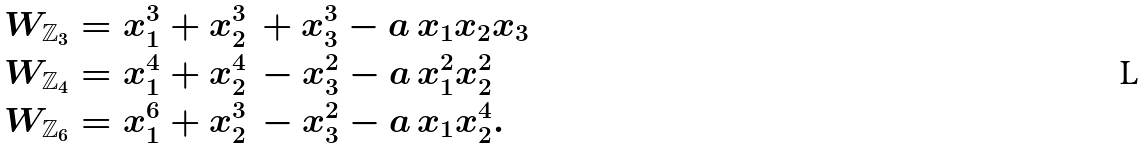Convert formula to latex. <formula><loc_0><loc_0><loc_500><loc_500>W _ { \mathbb { Z } _ { 3 } } & = x _ { 1 } ^ { 3 } + x _ { 2 } ^ { 3 } \, + x _ { 3 } ^ { 3 } - a \, x _ { 1 } x _ { 2 } x _ { 3 } \\ W _ { \mathbb { Z } _ { 4 } } & = x _ { 1 } ^ { 4 } + x _ { 2 } ^ { 4 } \, - x _ { 3 } ^ { 2 } - a \, x _ { 1 } ^ { 2 } x _ { 2 } ^ { 2 } \\ W _ { \mathbb { Z } _ { 6 } } & = x _ { 1 } ^ { 6 } + x _ { 2 } ^ { 3 } \, - x _ { 3 } ^ { 2 } - a \, x _ { 1 } x _ { 2 } ^ { 4 } .</formula> 